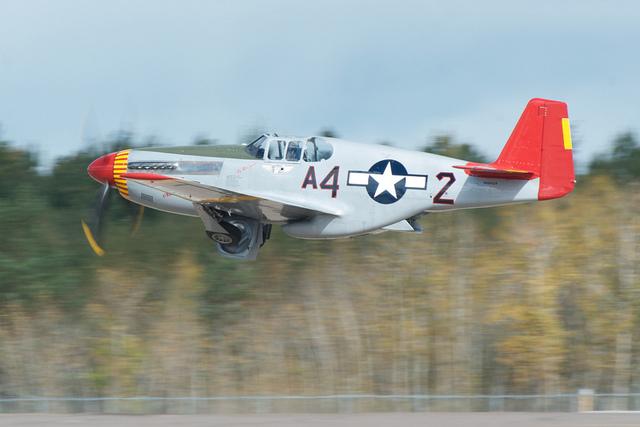Is this a jet aircraft?
Write a very short answer. No. Is there a star in the scene?
Concise answer only. Yes. Is this a commercial airplane?
Write a very short answer. No. 